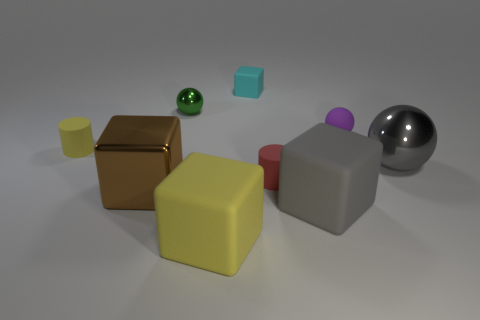Subtract all shiny balls. How many balls are left? 1 Subtract all spheres. How many objects are left? 6 Subtract all brown cubes. How many cubes are left? 3 Subtract 1 blocks. How many blocks are left? 3 Subtract 1 gray blocks. How many objects are left? 8 Subtract all cyan balls. Subtract all green cylinders. How many balls are left? 3 Subtract all big brown rubber balls. Subtract all big rubber cubes. How many objects are left? 7 Add 2 brown things. How many brown things are left? 3 Add 4 balls. How many balls exist? 7 